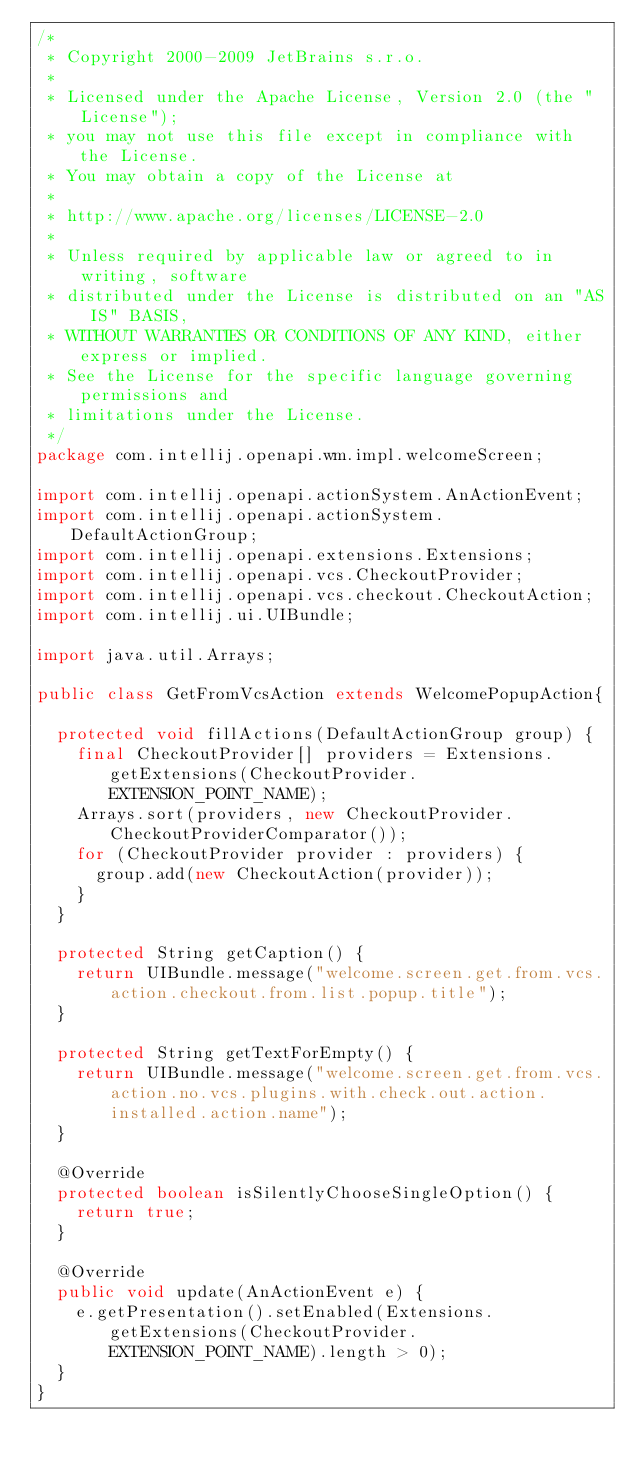<code> <loc_0><loc_0><loc_500><loc_500><_Java_>/*
 * Copyright 2000-2009 JetBrains s.r.o.
 *
 * Licensed under the Apache License, Version 2.0 (the "License");
 * you may not use this file except in compliance with the License.
 * You may obtain a copy of the License at
 *
 * http://www.apache.org/licenses/LICENSE-2.0
 *
 * Unless required by applicable law or agreed to in writing, software
 * distributed under the License is distributed on an "AS IS" BASIS,
 * WITHOUT WARRANTIES OR CONDITIONS OF ANY KIND, either express or implied.
 * See the License for the specific language governing permissions and
 * limitations under the License.
 */
package com.intellij.openapi.wm.impl.welcomeScreen;

import com.intellij.openapi.actionSystem.AnActionEvent;
import com.intellij.openapi.actionSystem.DefaultActionGroup;
import com.intellij.openapi.extensions.Extensions;
import com.intellij.openapi.vcs.CheckoutProvider;
import com.intellij.openapi.vcs.checkout.CheckoutAction;
import com.intellij.ui.UIBundle;

import java.util.Arrays;

public class GetFromVcsAction extends WelcomePopupAction{

  protected void fillActions(DefaultActionGroup group) {
    final CheckoutProvider[] providers = Extensions.getExtensions(CheckoutProvider.EXTENSION_POINT_NAME);
    Arrays.sort(providers, new CheckoutProvider.CheckoutProviderComparator());
    for (CheckoutProvider provider : providers) {
      group.add(new CheckoutAction(provider));
    }
  }

  protected String getCaption() {
    return UIBundle.message("welcome.screen.get.from.vcs.action.checkout.from.list.popup.title");
  }

  protected String getTextForEmpty() {
    return UIBundle.message("welcome.screen.get.from.vcs.action.no.vcs.plugins.with.check.out.action.installed.action.name");
  }

  @Override
  protected boolean isSilentlyChooseSingleOption() {
    return true;
  }

  @Override
  public void update(AnActionEvent e) {
    e.getPresentation().setEnabled(Extensions.getExtensions(CheckoutProvider.EXTENSION_POINT_NAME).length > 0);
  }
}
</code> 